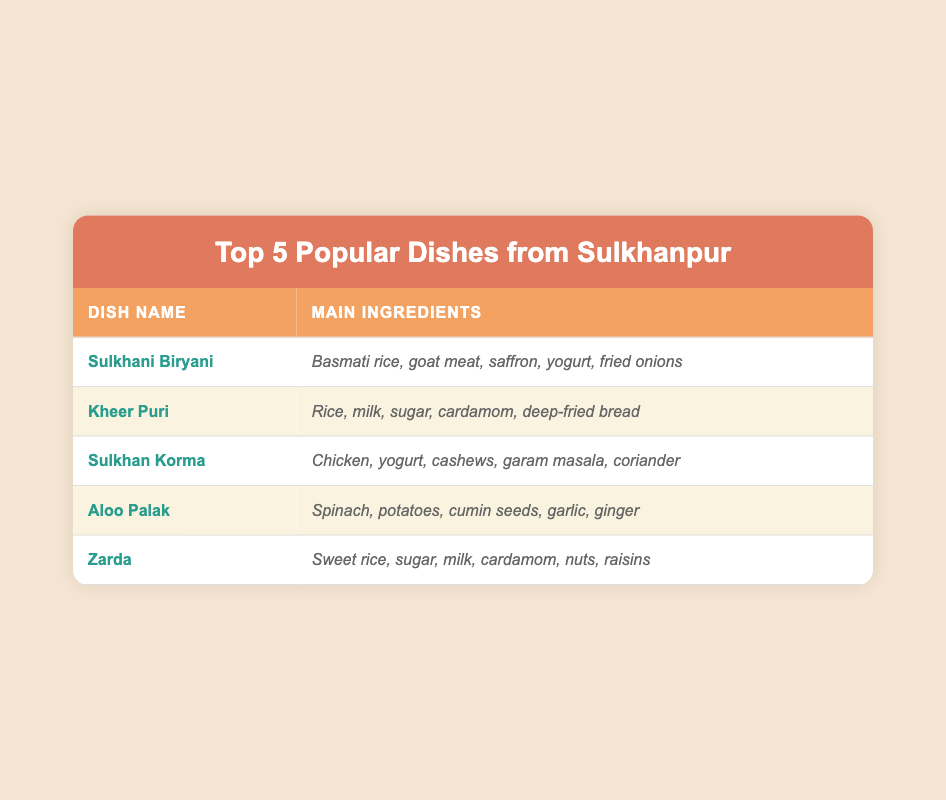What is the main ingredient of Sulkhani Biryani? According to the table, the main ingredients of Sulkhani Biryani include basmati rice, goat meat, saffron, yogurt, and fried onions. Therefore, any of these can be considered main ingredients, but to answer the question specifically, basmati rice is often regarded as the primary component in biryani.
Answer: Basmati rice Which dish contains yogurt as one of its main ingredients? Looking through the table, Sulkhani Biryani, Sulkhan Korma, and Aloo Palak all list yogurt as a main ingredient. Thus, multiple dishes contain yogurt, but to answer the question, Sulkhan Korma is one such dish that prominently features yogurt.
Answer: Sulkhan Korma How many ingredients does Kheer Puri have? The table indicates that Kheer Puri has five main ingredients: rice, milk, sugar, cardamom, and deep-fried bread. Therefore, counting all the ingredients provides us with a total of five.
Answer: 5 Is Zarda a savory dish? The ingredients for Zarda include sweet rice, sugar, milk, cardamom, nuts, and raisins, which are typically associated with sweet dishes. Therefore, Zarda is not a savory dish, making the statement false.
Answer: No What is the average number of ingredients across all dishes? We count the number of ingredients for each dish: Sulkhani Biryani (5), Kheer Puri (5), Sulkhan Korma (5), Aloo Palak (5), and Zarda (6). Adding these gives a total of 26 ingredients. Since there are 5 dishes, the average is calculated as 26 divided by 5, resulting in 5.2.
Answer: 5.2 